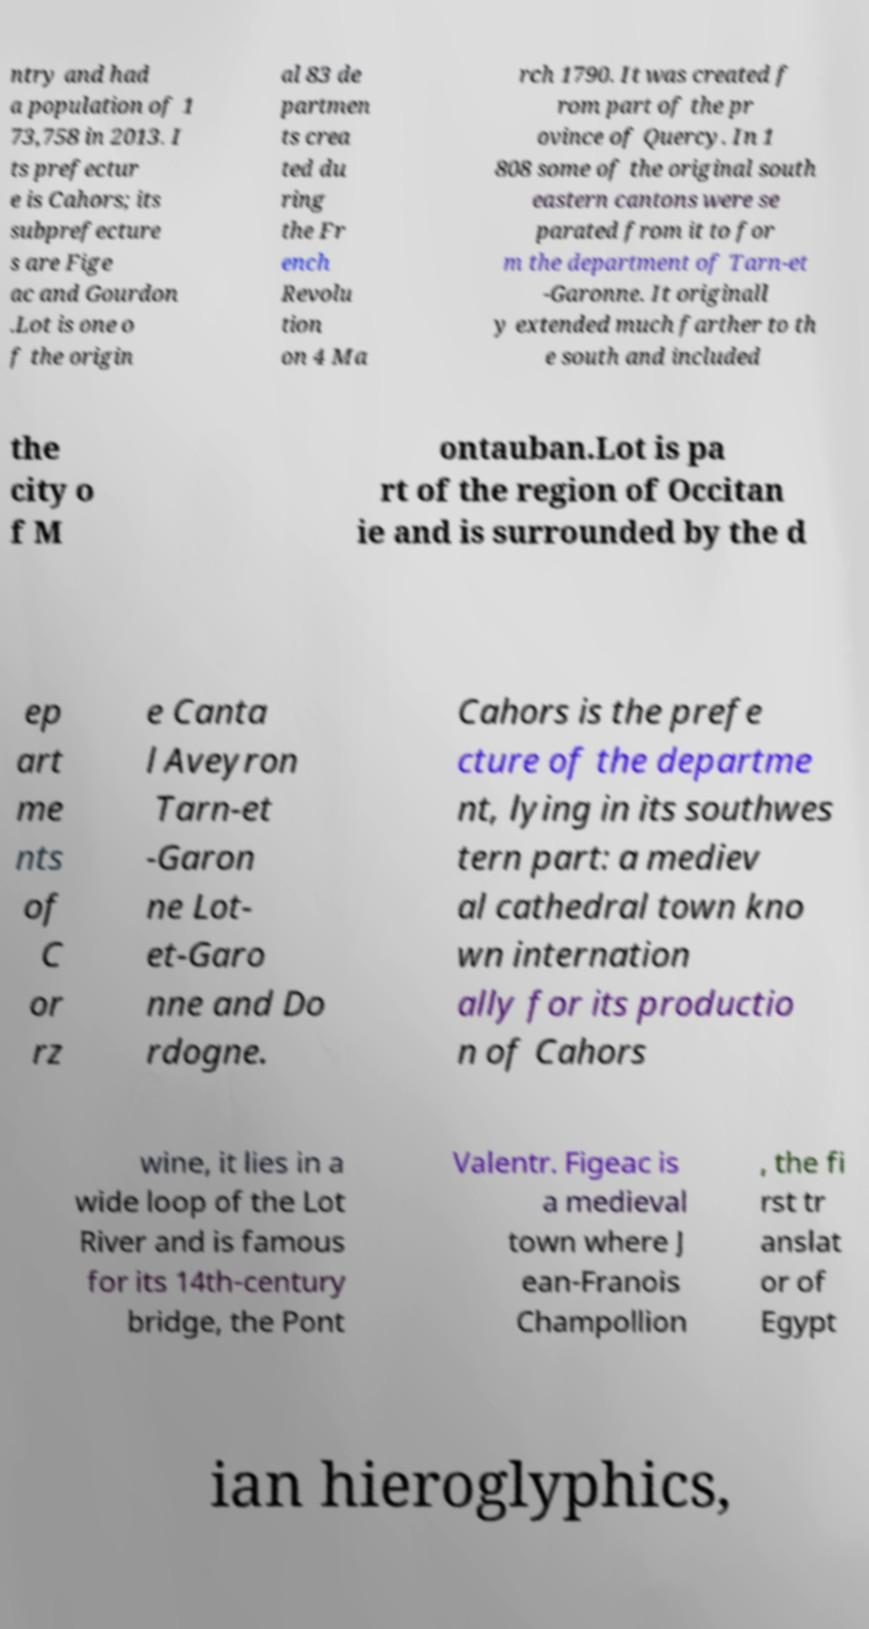There's text embedded in this image that I need extracted. Can you transcribe it verbatim? ntry and had a population of 1 73,758 in 2013. I ts prefectur e is Cahors; its subprefecture s are Fige ac and Gourdon .Lot is one o f the origin al 83 de partmen ts crea ted du ring the Fr ench Revolu tion on 4 Ma rch 1790. It was created f rom part of the pr ovince of Quercy. In 1 808 some of the original south eastern cantons were se parated from it to for m the department of Tarn-et -Garonne. It originall y extended much farther to th e south and included the city o f M ontauban.Lot is pa rt of the region of Occitan ie and is surrounded by the d ep art me nts of C or rz e Canta l Aveyron Tarn-et -Garon ne Lot- et-Garo nne and Do rdogne. Cahors is the prefe cture of the departme nt, lying in its southwes tern part: a mediev al cathedral town kno wn internation ally for its productio n of Cahors wine, it lies in a wide loop of the Lot River and is famous for its 14th-century bridge, the Pont Valentr. Figeac is a medieval town where J ean-Franois Champollion , the fi rst tr anslat or of Egypt ian hieroglyphics, 